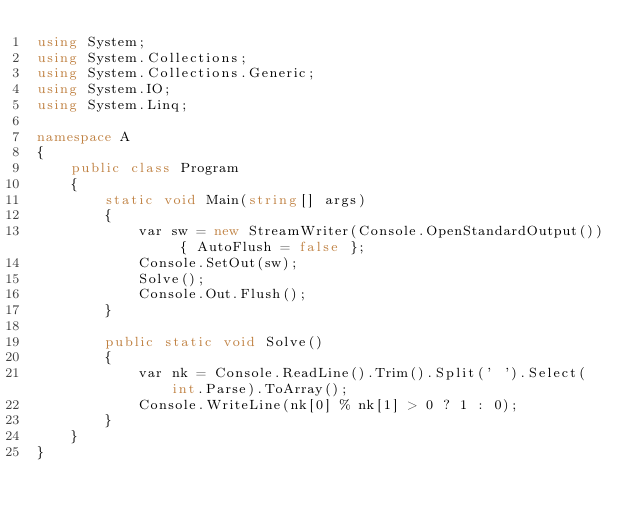<code> <loc_0><loc_0><loc_500><loc_500><_C#_>using System;
using System.Collections;
using System.Collections.Generic;
using System.IO;
using System.Linq;

namespace A
{
    public class Program
    {
        static void Main(string[] args)
        {
            var sw = new StreamWriter(Console.OpenStandardOutput()) { AutoFlush = false };
            Console.SetOut(sw);
            Solve();
            Console.Out.Flush();
        }

        public static void Solve()
        {
            var nk = Console.ReadLine().Trim().Split(' ').Select(int.Parse).ToArray();
            Console.WriteLine(nk[0] % nk[1] > 0 ? 1 : 0);
        }
    }
}
</code> 